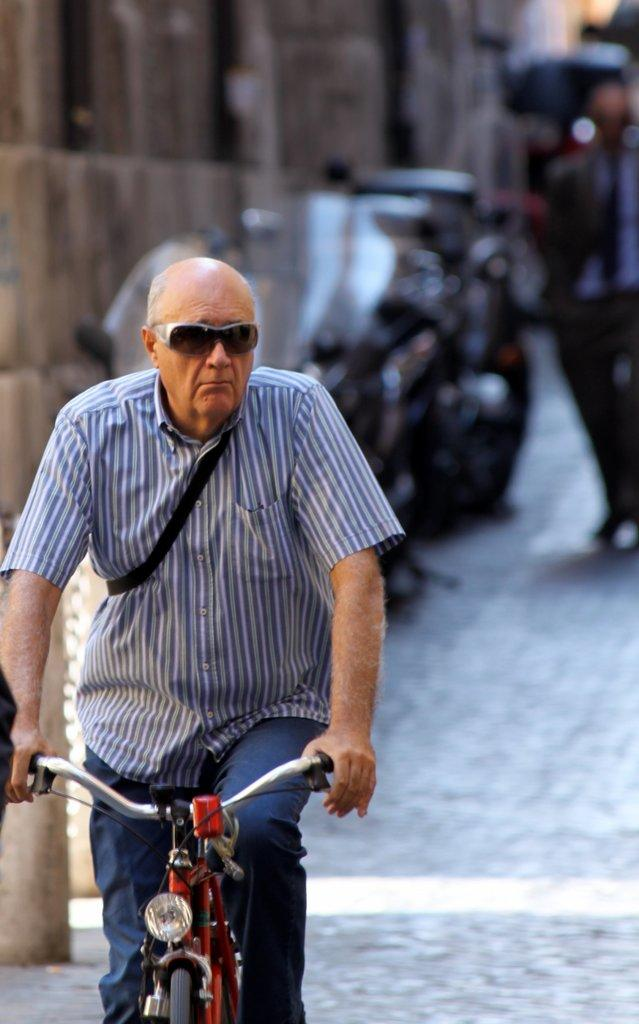Who is the main subject in the image? There is an old man in the image. What is the old man doing in the image? The old man is riding a bicycle. What accessories is the old man wearing in the image? The old man is wearing sunglasses and a striped shirt. What can be seen in the background of the image? There are people, a vehicle, and a building in the background of the image. How would you describe the background of the image? The background is blurry. What type of trees can be seen in the old man's thoughts in the image? There are no trees visible in the old man's thoughts, as thoughts cannot be seen in an image. 